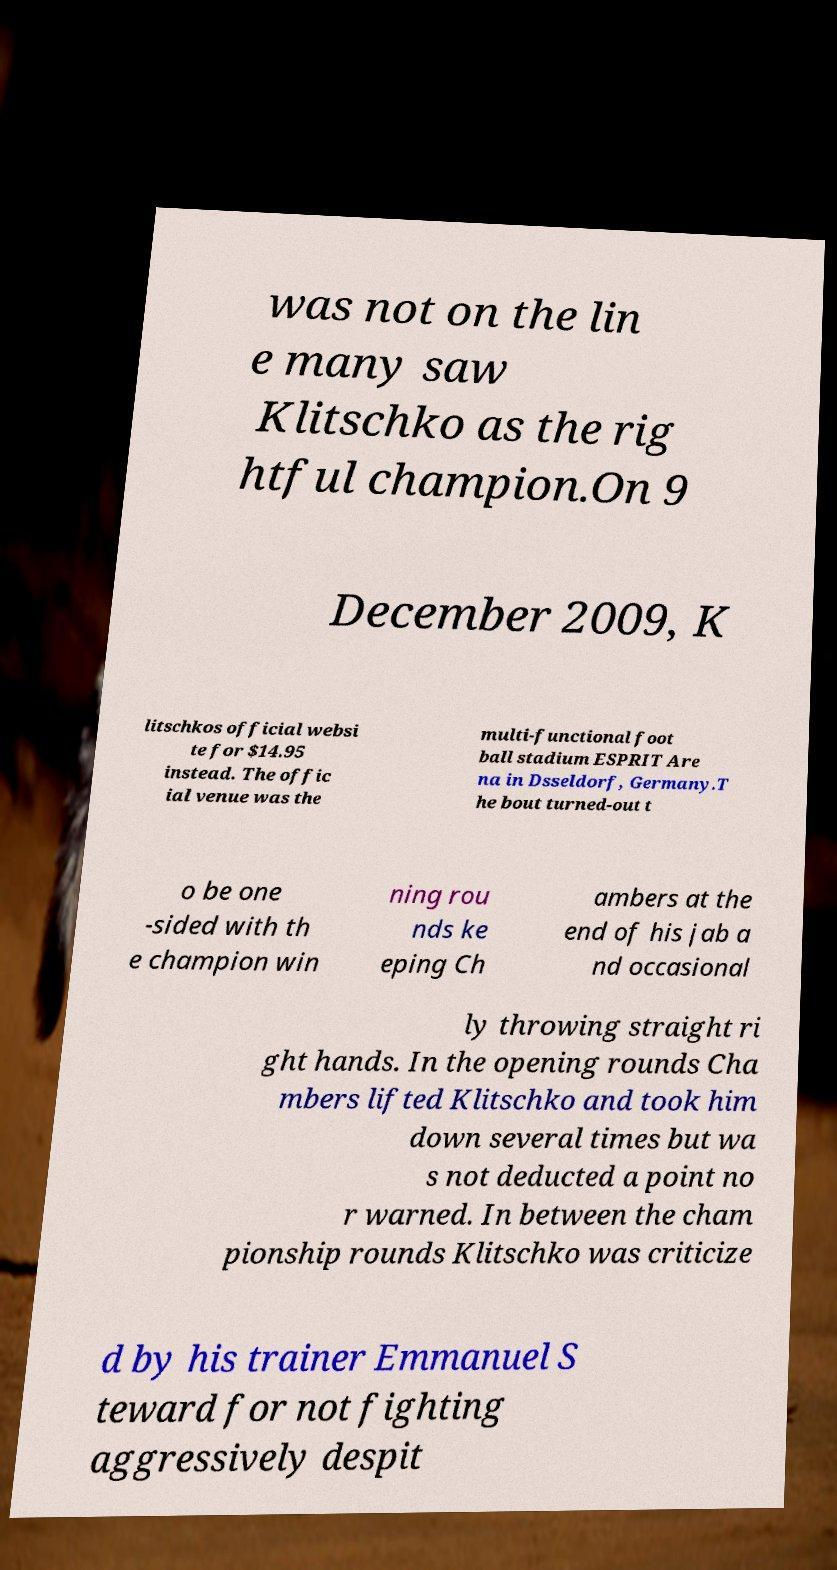Please read and relay the text visible in this image. What does it say? was not on the lin e many saw Klitschko as the rig htful champion.On 9 December 2009, K litschkos official websi te for $14.95 instead. The offic ial venue was the multi-functional foot ball stadium ESPRIT Are na in Dsseldorf, Germany.T he bout turned-out t o be one -sided with th e champion win ning rou nds ke eping Ch ambers at the end of his jab a nd occasional ly throwing straight ri ght hands. In the opening rounds Cha mbers lifted Klitschko and took him down several times but wa s not deducted a point no r warned. In between the cham pionship rounds Klitschko was criticize d by his trainer Emmanuel S teward for not fighting aggressively despit 